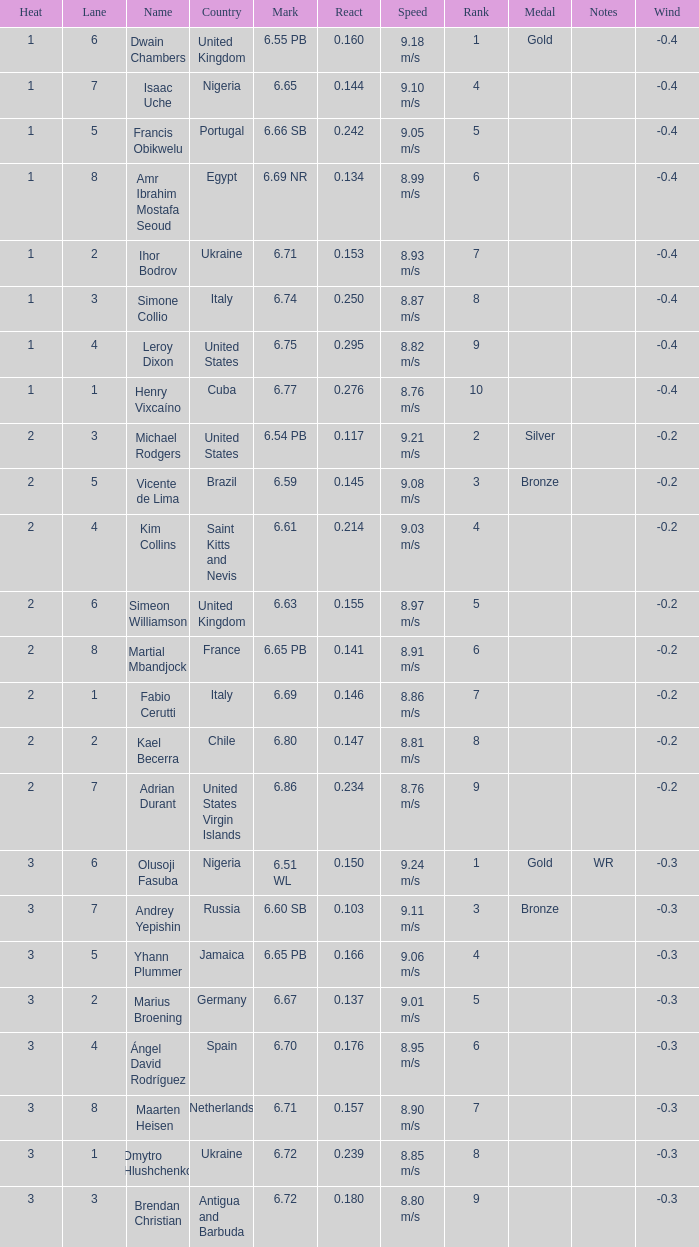What is the lowest Lane, when Country is France, and when React is less than 0.14100000000000001? 8.0. 